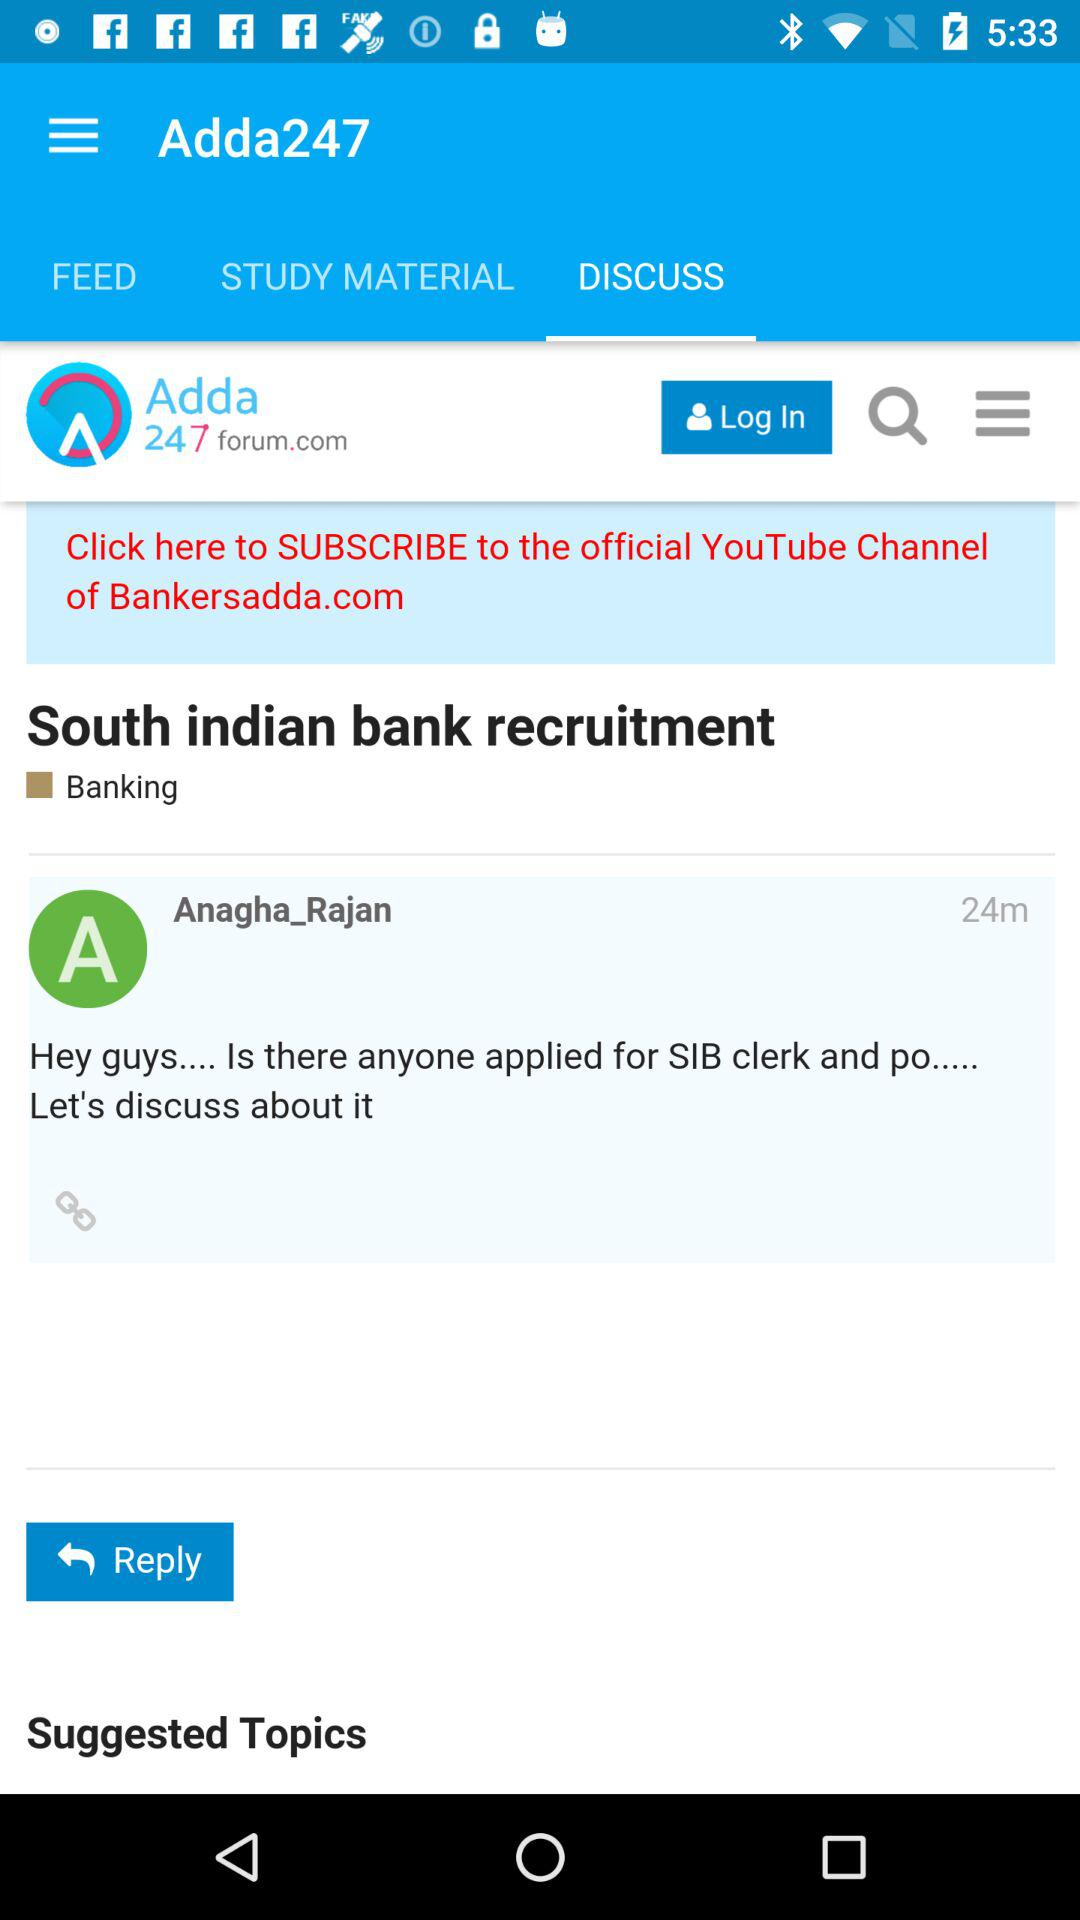What is the app's name? The app's name is Adda247. 